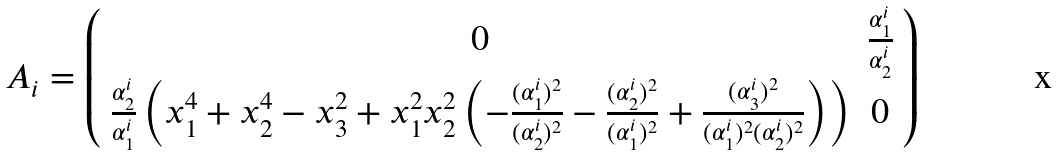<formula> <loc_0><loc_0><loc_500><loc_500>A _ { i } & = \left ( \begin{array} { c c } 0 & \frac { \alpha _ { 1 } ^ { i } } { \alpha _ { 2 } ^ { i } } \\ \frac { \alpha _ { 2 } ^ { i } } { \alpha _ { 1 } ^ { i } } \left ( x _ { 1 } ^ { 4 } + x _ { 2 } ^ { 4 } - x _ { 3 } ^ { 2 } + x _ { 1 } ^ { 2 } x _ { 2 } ^ { 2 } \left ( - \frac { ( \alpha _ { 1 } ^ { i } ) ^ { 2 } } { ( \alpha _ { 2 } ^ { i } ) ^ { 2 } } - \frac { ( \alpha _ { 2 } ^ { i } ) ^ { 2 } } { ( \alpha _ { 1 } ^ { i } ) ^ { 2 } } + \frac { ( \alpha _ { 3 } ^ { i } ) ^ { 2 } } { ( \alpha _ { 1 } ^ { i } ) ^ { 2 } ( \alpha _ { 2 } ^ { i } ) ^ { 2 } } \right ) \right ) & 0 \end{array} \right )</formula> 